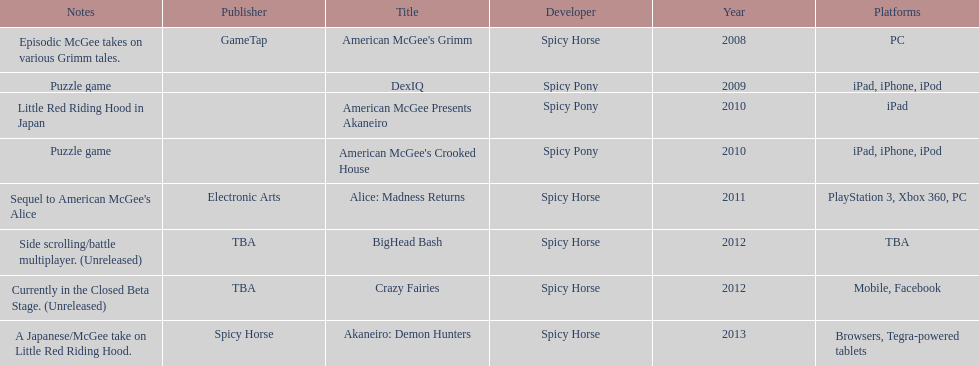According to the table, what is the last title that spicy horse produced? Akaneiro: Demon Hunters. 